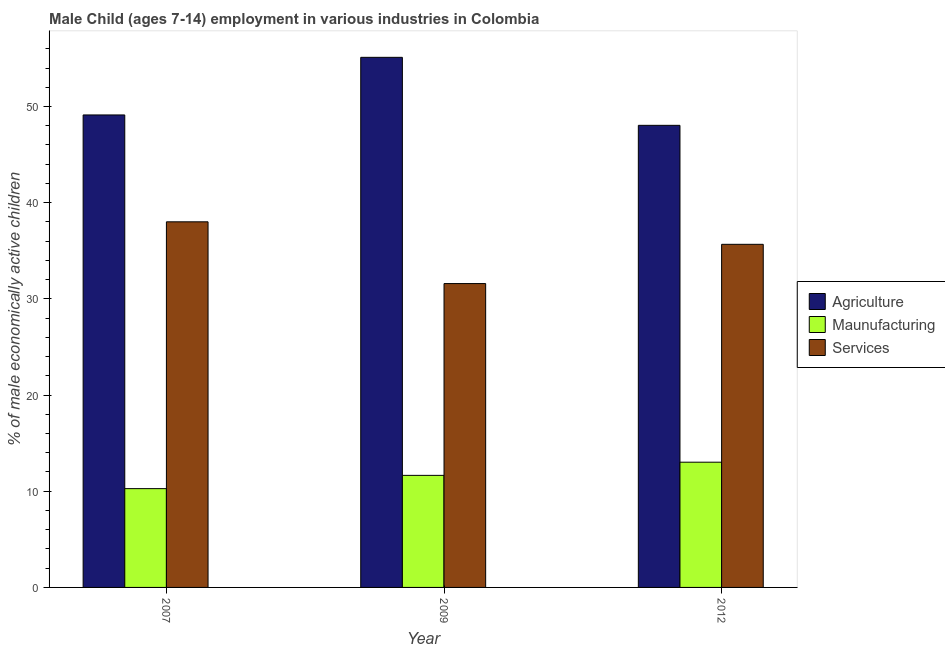How many groups of bars are there?
Ensure brevity in your answer.  3. Are the number of bars per tick equal to the number of legend labels?
Provide a succinct answer. Yes. How many bars are there on the 2nd tick from the right?
Provide a short and direct response. 3. What is the label of the 3rd group of bars from the left?
Keep it short and to the point. 2012. What is the percentage of economically active children in services in 2012?
Your response must be concise. 35.67. Across all years, what is the maximum percentage of economically active children in services?
Your response must be concise. 38.01. Across all years, what is the minimum percentage of economically active children in services?
Provide a short and direct response. 31.59. What is the total percentage of economically active children in manufacturing in the graph?
Offer a terse response. 34.94. What is the difference between the percentage of economically active children in services in 2007 and that in 2012?
Provide a short and direct response. 2.34. What is the difference between the percentage of economically active children in agriculture in 2009 and the percentage of economically active children in manufacturing in 2012?
Give a very brief answer. 7.07. What is the average percentage of economically active children in services per year?
Your response must be concise. 35.09. In how many years, is the percentage of economically active children in services greater than 28 %?
Provide a succinct answer. 3. What is the ratio of the percentage of economically active children in agriculture in 2007 to that in 2009?
Provide a succinct answer. 0.89. Is the difference between the percentage of economically active children in services in 2007 and 2012 greater than the difference between the percentage of economically active children in manufacturing in 2007 and 2012?
Provide a short and direct response. No. What is the difference between the highest and the second highest percentage of economically active children in manufacturing?
Keep it short and to the point. 1.37. What is the difference between the highest and the lowest percentage of economically active children in manufacturing?
Your answer should be compact. 2.75. In how many years, is the percentage of economically active children in services greater than the average percentage of economically active children in services taken over all years?
Your answer should be very brief. 2. What does the 1st bar from the left in 2007 represents?
Your answer should be compact. Agriculture. What does the 2nd bar from the right in 2007 represents?
Provide a succinct answer. Maunufacturing. Is it the case that in every year, the sum of the percentage of economically active children in agriculture and percentage of economically active children in manufacturing is greater than the percentage of economically active children in services?
Give a very brief answer. Yes. Where does the legend appear in the graph?
Provide a succinct answer. Center right. How many legend labels are there?
Provide a succinct answer. 3. What is the title of the graph?
Make the answer very short. Male Child (ages 7-14) employment in various industries in Colombia. What is the label or title of the X-axis?
Offer a very short reply. Year. What is the label or title of the Y-axis?
Your response must be concise. % of male economically active children. What is the % of male economically active children in Agriculture in 2007?
Give a very brief answer. 49.12. What is the % of male economically active children in Maunufacturing in 2007?
Your answer should be compact. 10.27. What is the % of male economically active children of Services in 2007?
Your answer should be compact. 38.01. What is the % of male economically active children of Agriculture in 2009?
Make the answer very short. 55.11. What is the % of male economically active children in Maunufacturing in 2009?
Keep it short and to the point. 11.65. What is the % of male economically active children in Services in 2009?
Ensure brevity in your answer.  31.59. What is the % of male economically active children of Agriculture in 2012?
Provide a short and direct response. 48.04. What is the % of male economically active children of Maunufacturing in 2012?
Offer a terse response. 13.02. What is the % of male economically active children of Services in 2012?
Provide a succinct answer. 35.67. Across all years, what is the maximum % of male economically active children in Agriculture?
Offer a terse response. 55.11. Across all years, what is the maximum % of male economically active children in Maunufacturing?
Provide a succinct answer. 13.02. Across all years, what is the maximum % of male economically active children of Services?
Your response must be concise. 38.01. Across all years, what is the minimum % of male economically active children in Agriculture?
Your answer should be compact. 48.04. Across all years, what is the minimum % of male economically active children in Maunufacturing?
Offer a terse response. 10.27. Across all years, what is the minimum % of male economically active children in Services?
Keep it short and to the point. 31.59. What is the total % of male economically active children of Agriculture in the graph?
Make the answer very short. 152.27. What is the total % of male economically active children in Maunufacturing in the graph?
Provide a succinct answer. 34.94. What is the total % of male economically active children of Services in the graph?
Your answer should be very brief. 105.27. What is the difference between the % of male economically active children of Agriculture in 2007 and that in 2009?
Give a very brief answer. -5.99. What is the difference between the % of male economically active children in Maunufacturing in 2007 and that in 2009?
Offer a terse response. -1.38. What is the difference between the % of male economically active children in Services in 2007 and that in 2009?
Your answer should be very brief. 6.42. What is the difference between the % of male economically active children of Agriculture in 2007 and that in 2012?
Your response must be concise. 1.08. What is the difference between the % of male economically active children in Maunufacturing in 2007 and that in 2012?
Make the answer very short. -2.75. What is the difference between the % of male economically active children in Services in 2007 and that in 2012?
Offer a very short reply. 2.34. What is the difference between the % of male economically active children in Agriculture in 2009 and that in 2012?
Your response must be concise. 7.07. What is the difference between the % of male economically active children in Maunufacturing in 2009 and that in 2012?
Ensure brevity in your answer.  -1.37. What is the difference between the % of male economically active children of Services in 2009 and that in 2012?
Provide a short and direct response. -4.08. What is the difference between the % of male economically active children in Agriculture in 2007 and the % of male economically active children in Maunufacturing in 2009?
Your answer should be compact. 37.47. What is the difference between the % of male economically active children in Agriculture in 2007 and the % of male economically active children in Services in 2009?
Give a very brief answer. 17.53. What is the difference between the % of male economically active children of Maunufacturing in 2007 and the % of male economically active children of Services in 2009?
Your response must be concise. -21.32. What is the difference between the % of male economically active children in Agriculture in 2007 and the % of male economically active children in Maunufacturing in 2012?
Your answer should be compact. 36.1. What is the difference between the % of male economically active children in Agriculture in 2007 and the % of male economically active children in Services in 2012?
Offer a very short reply. 13.45. What is the difference between the % of male economically active children in Maunufacturing in 2007 and the % of male economically active children in Services in 2012?
Ensure brevity in your answer.  -25.4. What is the difference between the % of male economically active children in Agriculture in 2009 and the % of male economically active children in Maunufacturing in 2012?
Your answer should be very brief. 42.09. What is the difference between the % of male economically active children in Agriculture in 2009 and the % of male economically active children in Services in 2012?
Ensure brevity in your answer.  19.44. What is the difference between the % of male economically active children in Maunufacturing in 2009 and the % of male economically active children in Services in 2012?
Your response must be concise. -24.02. What is the average % of male economically active children of Agriculture per year?
Give a very brief answer. 50.76. What is the average % of male economically active children of Maunufacturing per year?
Provide a succinct answer. 11.65. What is the average % of male economically active children in Services per year?
Offer a very short reply. 35.09. In the year 2007, what is the difference between the % of male economically active children of Agriculture and % of male economically active children of Maunufacturing?
Give a very brief answer. 38.85. In the year 2007, what is the difference between the % of male economically active children in Agriculture and % of male economically active children in Services?
Give a very brief answer. 11.11. In the year 2007, what is the difference between the % of male economically active children in Maunufacturing and % of male economically active children in Services?
Make the answer very short. -27.74. In the year 2009, what is the difference between the % of male economically active children of Agriculture and % of male economically active children of Maunufacturing?
Offer a very short reply. 43.46. In the year 2009, what is the difference between the % of male economically active children of Agriculture and % of male economically active children of Services?
Make the answer very short. 23.52. In the year 2009, what is the difference between the % of male economically active children in Maunufacturing and % of male economically active children in Services?
Keep it short and to the point. -19.94. In the year 2012, what is the difference between the % of male economically active children of Agriculture and % of male economically active children of Maunufacturing?
Your response must be concise. 35.02. In the year 2012, what is the difference between the % of male economically active children of Agriculture and % of male economically active children of Services?
Offer a very short reply. 12.37. In the year 2012, what is the difference between the % of male economically active children of Maunufacturing and % of male economically active children of Services?
Provide a succinct answer. -22.65. What is the ratio of the % of male economically active children of Agriculture in 2007 to that in 2009?
Keep it short and to the point. 0.89. What is the ratio of the % of male economically active children of Maunufacturing in 2007 to that in 2009?
Give a very brief answer. 0.88. What is the ratio of the % of male economically active children of Services in 2007 to that in 2009?
Keep it short and to the point. 1.2. What is the ratio of the % of male economically active children in Agriculture in 2007 to that in 2012?
Your response must be concise. 1.02. What is the ratio of the % of male economically active children in Maunufacturing in 2007 to that in 2012?
Ensure brevity in your answer.  0.79. What is the ratio of the % of male economically active children of Services in 2007 to that in 2012?
Your answer should be compact. 1.07. What is the ratio of the % of male economically active children of Agriculture in 2009 to that in 2012?
Your answer should be compact. 1.15. What is the ratio of the % of male economically active children of Maunufacturing in 2009 to that in 2012?
Offer a very short reply. 0.89. What is the ratio of the % of male economically active children in Services in 2009 to that in 2012?
Provide a short and direct response. 0.89. What is the difference between the highest and the second highest % of male economically active children of Agriculture?
Provide a short and direct response. 5.99. What is the difference between the highest and the second highest % of male economically active children of Maunufacturing?
Give a very brief answer. 1.37. What is the difference between the highest and the second highest % of male economically active children of Services?
Your response must be concise. 2.34. What is the difference between the highest and the lowest % of male economically active children of Agriculture?
Keep it short and to the point. 7.07. What is the difference between the highest and the lowest % of male economically active children in Maunufacturing?
Make the answer very short. 2.75. What is the difference between the highest and the lowest % of male economically active children of Services?
Give a very brief answer. 6.42. 